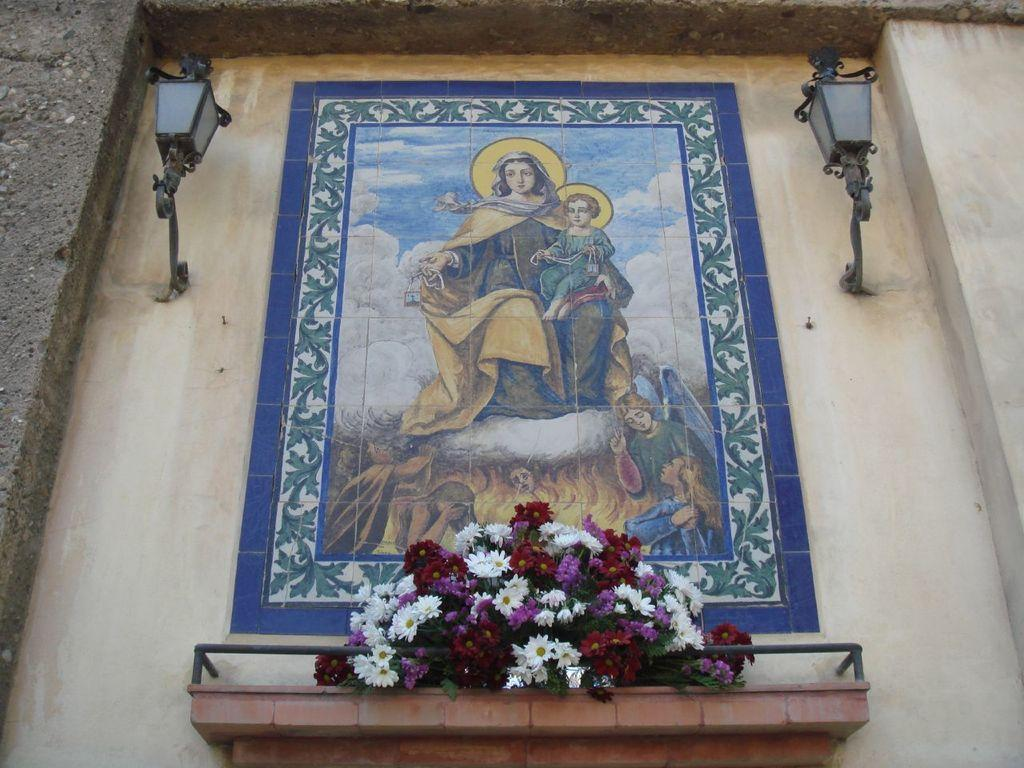What is depicted on the wall in the image? There is a painting on the wall in the image. What can be seen in the foreground of the image? There are flowers in the foreground of the image. What is visible in the background of the image? There are lights visible in the background of the image. How many chickens are sleeping on the painting in the image? There are no chickens present in the image, and the painting does not depict any sleeping animals. 